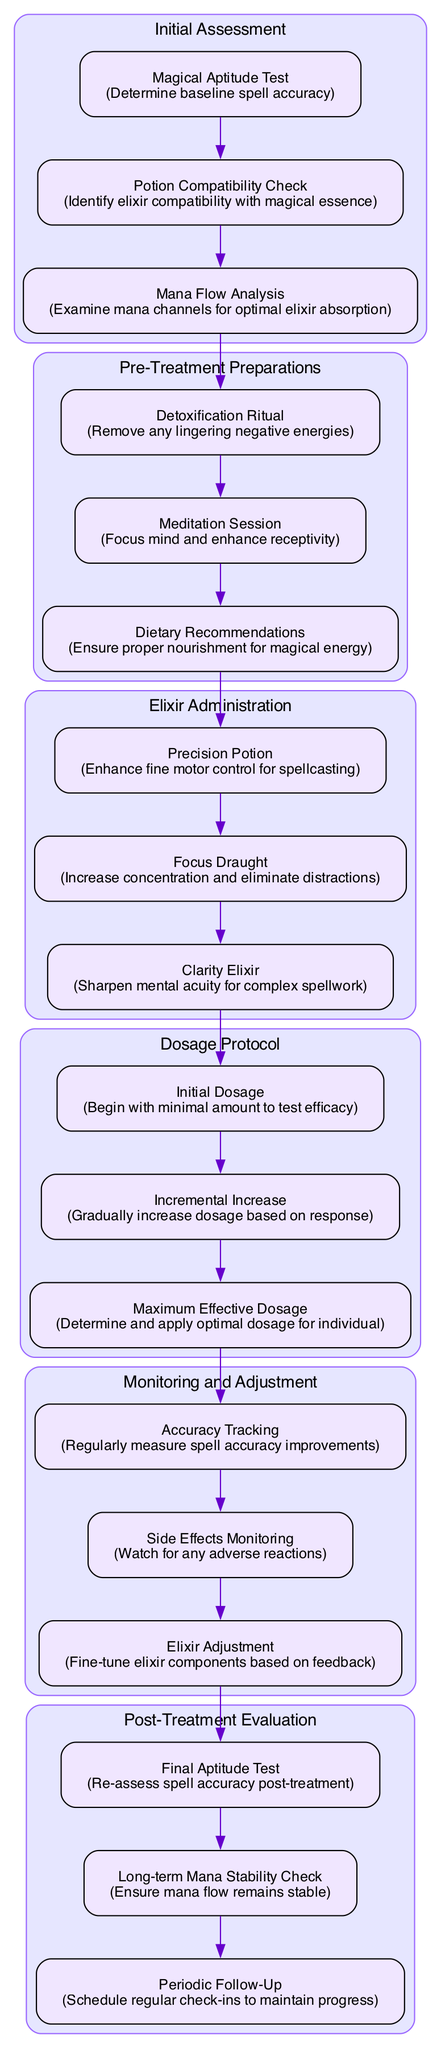What is the first step in the treatment pathway? The first step listed in the treatment pathway is "Magical Aptitude Test," which is part of the "Initial Assessment."
Answer: Magical Aptitude Test How many steps are in the "Elixir Administration" stage? The "Elixir Administration" stage contains three steps: "Precision Potion," "Focus Draught," and "Clarity Elixir."
Answer: 3 Which step follows "Detoxification Ritual"? The step that follows "Detoxification Ritual" is "Meditation Session" in the "Pre-Treatment Preparations" section.
Answer: Meditation Session What is the purpose of the "Focus Draught"? The "Focus Draught" is intended to increase concentration and eliminate distractions during spellcasting.
Answer: Increase concentration What is the relationship between "Initial Dosage" and "Incremental Increase"? "Incremental Increase" follows "Initial Dosage," indicating that after beginning with a minimal amount, the dosage should be gradually increased based on the response.
Answer: "Incremental Increase" follows "Initial Dosage" Name the last step in the "Post-Treatment Evaluation." The last step in the "Post-Treatment Evaluation" is "Periodic Follow-Up."
Answer: Periodic Follow-Up How is the "Accuracy Tracking" linked to "Elixir Adjustment"? "Accuracy Tracking" precedes "Elixir Adjustment," suggesting that spell accuracy improvements need to be measured before adjustments are made to the elixir components.
Answer: "Accuracy Tracking" precedes "Elixir Adjustment" Which stage includes the "Mana Flow Analysis"? The "Mana Flow Analysis" is included in the "Initial Assessment" stage of the treatment pathway.
Answer: Initial Assessment Explain the primary focus of the "Post-Treatment Evaluation." The primary focus of the "Post-Treatment Evaluation" is to assess spell accuracy and ensure that mana flow remains stable after treatment completion, while also scheduling regular follow-ups.
Answer: Assess spell accuracy 